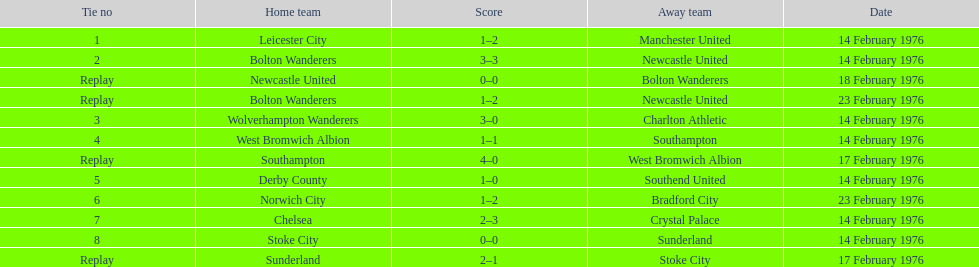How many teams were involved in playing on the 14th of february, 1976? 7. 